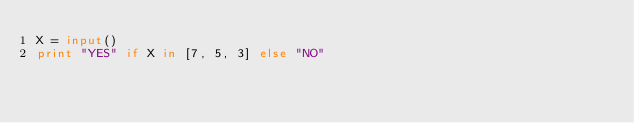<code> <loc_0><loc_0><loc_500><loc_500><_Python_>X = input()
print "YES" if X in [7, 5, 3] else "NO"
</code> 